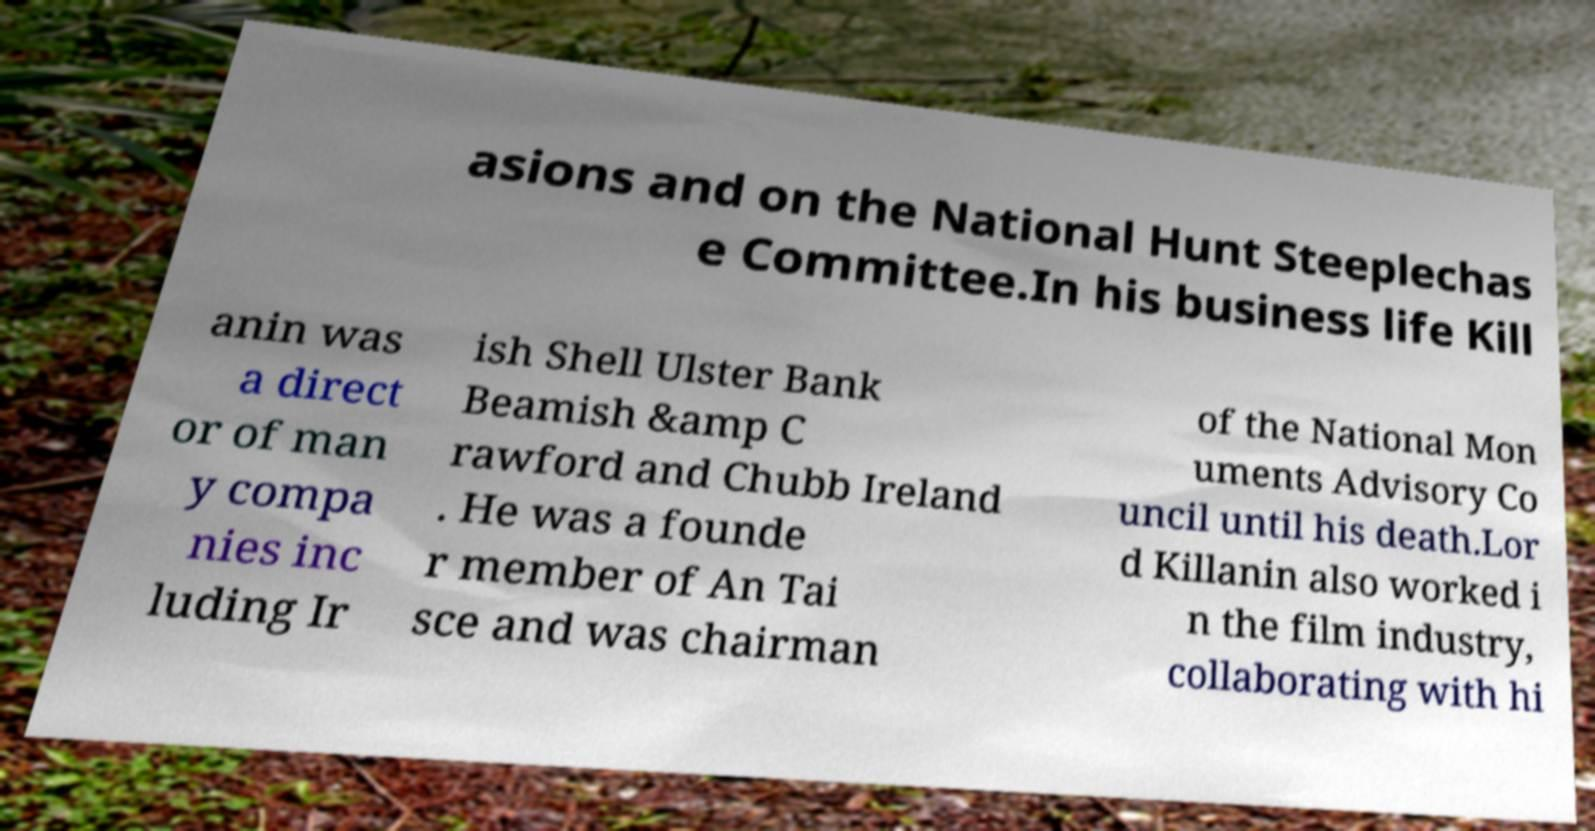Can you accurately transcribe the text from the provided image for me? asions and on the National Hunt Steeplechas e Committee.In his business life Kill anin was a direct or of man y compa nies inc luding Ir ish Shell Ulster Bank Beamish &amp C rawford and Chubb Ireland . He was a founde r member of An Tai sce and was chairman of the National Mon uments Advisory Co uncil until his death.Lor d Killanin also worked i n the film industry, collaborating with hi 